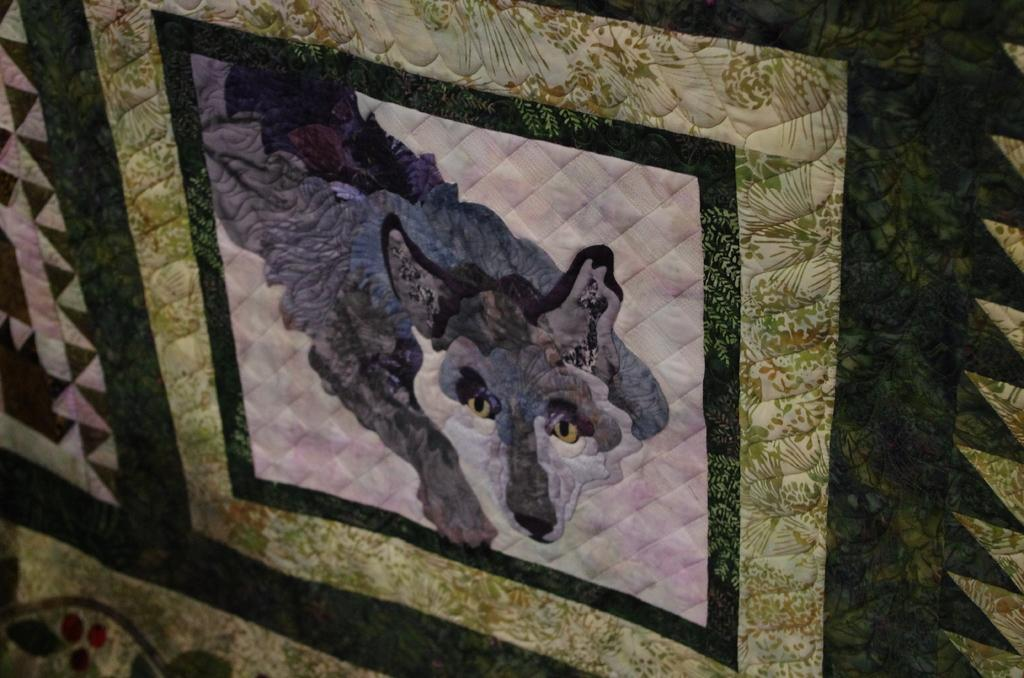What is depicted on the cloth in the image? There is a design of an animal on the cloth in the image. What type of property can be seen in the background of the image? There is no property visible in the image; it only shows a design of an animal on the cloth. 